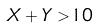Convert formula to latex. <formula><loc_0><loc_0><loc_500><loc_500>X + Y > 1 0</formula> 